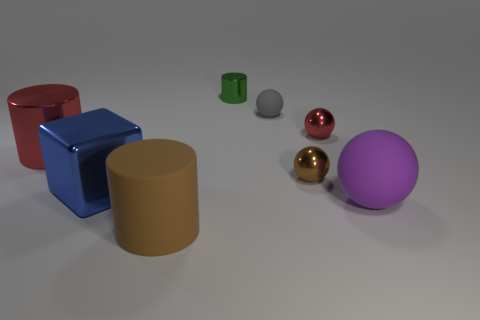How many matte objects are in front of the large red metallic thing and to the right of the large matte cylinder?
Offer a terse response. 1. Are the small green cylinder and the brown thing that is in front of the brown metallic thing made of the same material?
Your answer should be compact. No. What number of brown things are tiny balls or large balls?
Your answer should be compact. 1. Is there a red shiny cylinder of the same size as the purple rubber sphere?
Your response must be concise. Yes. What material is the tiny cylinder that is on the right side of the red thing left of the brown object that is left of the gray ball made of?
Your answer should be compact. Metal. Are there an equal number of green cylinders behind the small green object and small brown rubber spheres?
Provide a succinct answer. Yes. Do the big cylinder to the right of the blue metallic cube and the tiny sphere that is to the left of the small brown metal sphere have the same material?
Your response must be concise. Yes. How many things are small brown matte balls or metal objects left of the large blue cube?
Give a very brief answer. 1. Are there any tiny brown metal objects of the same shape as the small gray matte thing?
Offer a terse response. Yes. There is a red thing to the left of the red object right of the cylinder in front of the big metallic cylinder; what is its size?
Make the answer very short. Large. 